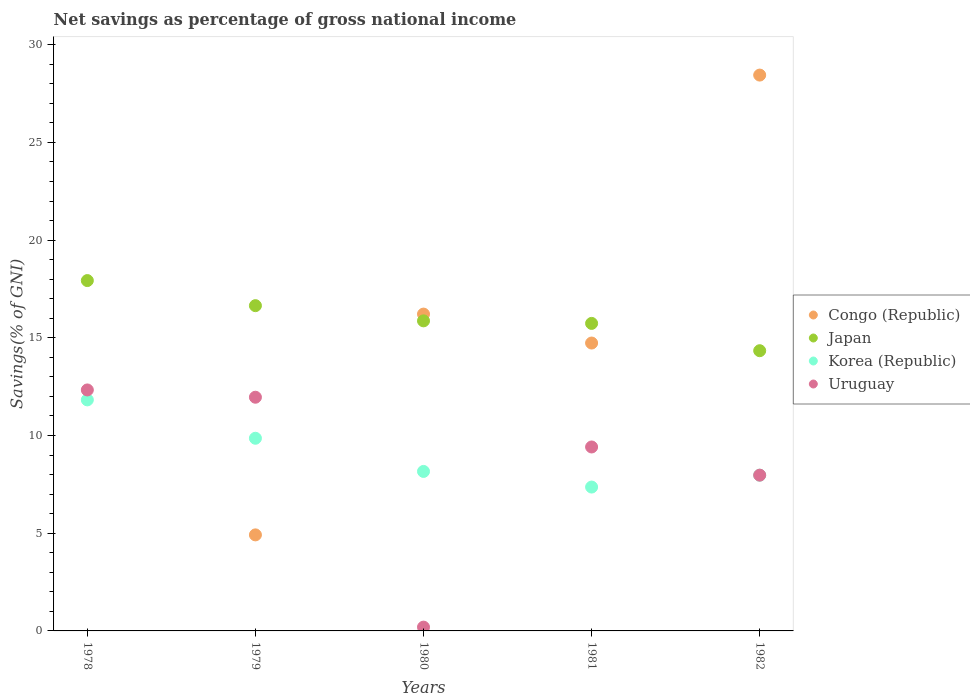What is the total savings in Korea (Republic) in 1979?
Make the answer very short. 9.86. Across all years, what is the maximum total savings in Japan?
Provide a short and direct response. 17.93. Across all years, what is the minimum total savings in Korea (Republic)?
Provide a short and direct response. 7.36. In which year was the total savings in Korea (Republic) maximum?
Give a very brief answer. 1978. What is the total total savings in Congo (Republic) in the graph?
Offer a terse response. 64.31. What is the difference between the total savings in Uruguay in 1979 and that in 1982?
Offer a terse response. 3.99. What is the difference between the total savings in Congo (Republic) in 1978 and the total savings in Uruguay in 1980?
Your answer should be compact. -0.19. What is the average total savings in Japan per year?
Your response must be concise. 16.11. In the year 1980, what is the difference between the total savings in Uruguay and total savings in Congo (Republic)?
Ensure brevity in your answer.  -16.02. What is the ratio of the total savings in Korea (Republic) in 1980 to that in 1982?
Your response must be concise. 1.02. Is the difference between the total savings in Uruguay in 1979 and 1980 greater than the difference between the total savings in Congo (Republic) in 1979 and 1980?
Offer a terse response. Yes. What is the difference between the highest and the second highest total savings in Uruguay?
Keep it short and to the point. 0.37. What is the difference between the highest and the lowest total savings in Uruguay?
Provide a short and direct response. 12.14. In how many years, is the total savings in Uruguay greater than the average total savings in Uruguay taken over all years?
Offer a terse response. 3. Does the total savings in Japan monotonically increase over the years?
Your response must be concise. No. Is the total savings in Japan strictly less than the total savings in Congo (Republic) over the years?
Your answer should be very brief. No. What is the difference between two consecutive major ticks on the Y-axis?
Your answer should be very brief. 5. Does the graph contain any zero values?
Keep it short and to the point. Yes. Does the graph contain grids?
Give a very brief answer. No. Where does the legend appear in the graph?
Your answer should be very brief. Center right. What is the title of the graph?
Provide a succinct answer. Net savings as percentage of gross national income. What is the label or title of the Y-axis?
Offer a very short reply. Savings(% of GNI). What is the Savings(% of GNI) of Japan in 1978?
Give a very brief answer. 17.93. What is the Savings(% of GNI) in Korea (Republic) in 1978?
Your response must be concise. 11.82. What is the Savings(% of GNI) in Uruguay in 1978?
Ensure brevity in your answer.  12.33. What is the Savings(% of GNI) in Congo (Republic) in 1979?
Offer a very short reply. 4.92. What is the Savings(% of GNI) in Japan in 1979?
Provide a short and direct response. 16.65. What is the Savings(% of GNI) of Korea (Republic) in 1979?
Provide a succinct answer. 9.86. What is the Savings(% of GNI) of Uruguay in 1979?
Give a very brief answer. 11.96. What is the Savings(% of GNI) of Congo (Republic) in 1980?
Your answer should be very brief. 16.22. What is the Savings(% of GNI) in Japan in 1980?
Keep it short and to the point. 15.87. What is the Savings(% of GNI) in Korea (Republic) in 1980?
Your answer should be very brief. 8.16. What is the Savings(% of GNI) in Uruguay in 1980?
Provide a succinct answer. 0.19. What is the Savings(% of GNI) in Congo (Republic) in 1981?
Provide a short and direct response. 14.73. What is the Savings(% of GNI) in Japan in 1981?
Make the answer very short. 15.74. What is the Savings(% of GNI) of Korea (Republic) in 1981?
Your response must be concise. 7.36. What is the Savings(% of GNI) in Uruguay in 1981?
Offer a very short reply. 9.41. What is the Savings(% of GNI) of Congo (Republic) in 1982?
Offer a very short reply. 28.45. What is the Savings(% of GNI) in Japan in 1982?
Provide a short and direct response. 14.34. What is the Savings(% of GNI) in Korea (Republic) in 1982?
Your answer should be compact. 7.97. What is the Savings(% of GNI) in Uruguay in 1982?
Offer a very short reply. 7.97. Across all years, what is the maximum Savings(% of GNI) of Congo (Republic)?
Your answer should be very brief. 28.45. Across all years, what is the maximum Savings(% of GNI) in Japan?
Make the answer very short. 17.93. Across all years, what is the maximum Savings(% of GNI) in Korea (Republic)?
Your answer should be very brief. 11.82. Across all years, what is the maximum Savings(% of GNI) in Uruguay?
Give a very brief answer. 12.33. Across all years, what is the minimum Savings(% of GNI) of Japan?
Provide a succinct answer. 14.34. Across all years, what is the minimum Savings(% of GNI) in Korea (Republic)?
Make the answer very short. 7.36. Across all years, what is the minimum Savings(% of GNI) of Uruguay?
Your answer should be very brief. 0.19. What is the total Savings(% of GNI) of Congo (Republic) in the graph?
Your answer should be very brief. 64.31. What is the total Savings(% of GNI) in Japan in the graph?
Your response must be concise. 80.53. What is the total Savings(% of GNI) of Korea (Republic) in the graph?
Give a very brief answer. 45.18. What is the total Savings(% of GNI) in Uruguay in the graph?
Your answer should be very brief. 41.87. What is the difference between the Savings(% of GNI) in Japan in 1978 and that in 1979?
Offer a terse response. 1.28. What is the difference between the Savings(% of GNI) in Korea (Republic) in 1978 and that in 1979?
Ensure brevity in your answer.  1.96. What is the difference between the Savings(% of GNI) of Uruguay in 1978 and that in 1979?
Provide a succinct answer. 0.37. What is the difference between the Savings(% of GNI) of Japan in 1978 and that in 1980?
Give a very brief answer. 2.06. What is the difference between the Savings(% of GNI) of Korea (Republic) in 1978 and that in 1980?
Your response must be concise. 3.66. What is the difference between the Savings(% of GNI) of Uruguay in 1978 and that in 1980?
Give a very brief answer. 12.14. What is the difference between the Savings(% of GNI) in Japan in 1978 and that in 1981?
Your answer should be very brief. 2.19. What is the difference between the Savings(% of GNI) in Korea (Republic) in 1978 and that in 1981?
Provide a succinct answer. 4.46. What is the difference between the Savings(% of GNI) in Uruguay in 1978 and that in 1981?
Offer a very short reply. 2.92. What is the difference between the Savings(% of GNI) in Japan in 1978 and that in 1982?
Provide a short and direct response. 3.59. What is the difference between the Savings(% of GNI) in Korea (Republic) in 1978 and that in 1982?
Offer a very short reply. 3.85. What is the difference between the Savings(% of GNI) of Uruguay in 1978 and that in 1982?
Provide a succinct answer. 4.36. What is the difference between the Savings(% of GNI) of Congo (Republic) in 1979 and that in 1980?
Offer a terse response. -11.3. What is the difference between the Savings(% of GNI) of Korea (Republic) in 1979 and that in 1980?
Make the answer very short. 1.7. What is the difference between the Savings(% of GNI) in Uruguay in 1979 and that in 1980?
Offer a very short reply. 11.77. What is the difference between the Savings(% of GNI) of Congo (Republic) in 1979 and that in 1981?
Your answer should be compact. -9.82. What is the difference between the Savings(% of GNI) of Japan in 1979 and that in 1981?
Your response must be concise. 0.91. What is the difference between the Savings(% of GNI) of Korea (Republic) in 1979 and that in 1981?
Ensure brevity in your answer.  2.5. What is the difference between the Savings(% of GNI) in Uruguay in 1979 and that in 1981?
Give a very brief answer. 2.55. What is the difference between the Savings(% of GNI) in Congo (Republic) in 1979 and that in 1982?
Your response must be concise. -23.53. What is the difference between the Savings(% of GNI) in Japan in 1979 and that in 1982?
Offer a terse response. 2.31. What is the difference between the Savings(% of GNI) in Korea (Republic) in 1979 and that in 1982?
Your response must be concise. 1.89. What is the difference between the Savings(% of GNI) of Uruguay in 1979 and that in 1982?
Keep it short and to the point. 3.99. What is the difference between the Savings(% of GNI) in Congo (Republic) in 1980 and that in 1981?
Provide a short and direct response. 1.48. What is the difference between the Savings(% of GNI) in Japan in 1980 and that in 1981?
Offer a terse response. 0.13. What is the difference between the Savings(% of GNI) of Korea (Republic) in 1980 and that in 1981?
Keep it short and to the point. 0.8. What is the difference between the Savings(% of GNI) of Uruguay in 1980 and that in 1981?
Keep it short and to the point. -9.22. What is the difference between the Savings(% of GNI) of Congo (Republic) in 1980 and that in 1982?
Make the answer very short. -12.23. What is the difference between the Savings(% of GNI) in Japan in 1980 and that in 1982?
Your response must be concise. 1.53. What is the difference between the Savings(% of GNI) in Korea (Republic) in 1980 and that in 1982?
Ensure brevity in your answer.  0.19. What is the difference between the Savings(% of GNI) of Uruguay in 1980 and that in 1982?
Provide a short and direct response. -7.78. What is the difference between the Savings(% of GNI) of Congo (Republic) in 1981 and that in 1982?
Your response must be concise. -13.71. What is the difference between the Savings(% of GNI) of Japan in 1981 and that in 1982?
Your response must be concise. 1.4. What is the difference between the Savings(% of GNI) of Korea (Republic) in 1981 and that in 1982?
Offer a very short reply. -0.61. What is the difference between the Savings(% of GNI) in Uruguay in 1981 and that in 1982?
Give a very brief answer. 1.44. What is the difference between the Savings(% of GNI) in Japan in 1978 and the Savings(% of GNI) in Korea (Republic) in 1979?
Ensure brevity in your answer.  8.07. What is the difference between the Savings(% of GNI) in Japan in 1978 and the Savings(% of GNI) in Uruguay in 1979?
Your response must be concise. 5.97. What is the difference between the Savings(% of GNI) in Korea (Republic) in 1978 and the Savings(% of GNI) in Uruguay in 1979?
Provide a succinct answer. -0.14. What is the difference between the Savings(% of GNI) in Japan in 1978 and the Savings(% of GNI) in Korea (Republic) in 1980?
Offer a very short reply. 9.77. What is the difference between the Savings(% of GNI) of Japan in 1978 and the Savings(% of GNI) of Uruguay in 1980?
Offer a terse response. 17.74. What is the difference between the Savings(% of GNI) in Korea (Republic) in 1978 and the Savings(% of GNI) in Uruguay in 1980?
Your response must be concise. 11.63. What is the difference between the Savings(% of GNI) of Japan in 1978 and the Savings(% of GNI) of Korea (Republic) in 1981?
Your answer should be very brief. 10.57. What is the difference between the Savings(% of GNI) in Japan in 1978 and the Savings(% of GNI) in Uruguay in 1981?
Offer a very short reply. 8.52. What is the difference between the Savings(% of GNI) in Korea (Republic) in 1978 and the Savings(% of GNI) in Uruguay in 1981?
Offer a terse response. 2.41. What is the difference between the Savings(% of GNI) of Japan in 1978 and the Savings(% of GNI) of Korea (Republic) in 1982?
Offer a very short reply. 9.96. What is the difference between the Savings(% of GNI) in Japan in 1978 and the Savings(% of GNI) in Uruguay in 1982?
Your answer should be compact. 9.96. What is the difference between the Savings(% of GNI) of Korea (Republic) in 1978 and the Savings(% of GNI) of Uruguay in 1982?
Your answer should be compact. 3.85. What is the difference between the Savings(% of GNI) in Congo (Republic) in 1979 and the Savings(% of GNI) in Japan in 1980?
Your response must be concise. -10.95. What is the difference between the Savings(% of GNI) in Congo (Republic) in 1979 and the Savings(% of GNI) in Korea (Republic) in 1980?
Your answer should be very brief. -3.25. What is the difference between the Savings(% of GNI) in Congo (Republic) in 1979 and the Savings(% of GNI) in Uruguay in 1980?
Ensure brevity in your answer.  4.72. What is the difference between the Savings(% of GNI) in Japan in 1979 and the Savings(% of GNI) in Korea (Republic) in 1980?
Keep it short and to the point. 8.48. What is the difference between the Savings(% of GNI) in Japan in 1979 and the Savings(% of GNI) in Uruguay in 1980?
Provide a succinct answer. 16.45. What is the difference between the Savings(% of GNI) in Korea (Republic) in 1979 and the Savings(% of GNI) in Uruguay in 1980?
Give a very brief answer. 9.67. What is the difference between the Savings(% of GNI) in Congo (Republic) in 1979 and the Savings(% of GNI) in Japan in 1981?
Your answer should be compact. -10.82. What is the difference between the Savings(% of GNI) of Congo (Republic) in 1979 and the Savings(% of GNI) of Korea (Republic) in 1981?
Keep it short and to the point. -2.45. What is the difference between the Savings(% of GNI) of Congo (Republic) in 1979 and the Savings(% of GNI) of Uruguay in 1981?
Your response must be concise. -4.5. What is the difference between the Savings(% of GNI) in Japan in 1979 and the Savings(% of GNI) in Korea (Republic) in 1981?
Keep it short and to the point. 9.28. What is the difference between the Savings(% of GNI) in Japan in 1979 and the Savings(% of GNI) in Uruguay in 1981?
Ensure brevity in your answer.  7.23. What is the difference between the Savings(% of GNI) in Korea (Republic) in 1979 and the Savings(% of GNI) in Uruguay in 1981?
Offer a very short reply. 0.45. What is the difference between the Savings(% of GNI) in Congo (Republic) in 1979 and the Savings(% of GNI) in Japan in 1982?
Your answer should be very brief. -9.43. What is the difference between the Savings(% of GNI) in Congo (Republic) in 1979 and the Savings(% of GNI) in Korea (Republic) in 1982?
Your answer should be compact. -3.05. What is the difference between the Savings(% of GNI) in Congo (Republic) in 1979 and the Savings(% of GNI) in Uruguay in 1982?
Provide a short and direct response. -3.06. What is the difference between the Savings(% of GNI) in Japan in 1979 and the Savings(% of GNI) in Korea (Republic) in 1982?
Give a very brief answer. 8.68. What is the difference between the Savings(% of GNI) in Japan in 1979 and the Savings(% of GNI) in Uruguay in 1982?
Ensure brevity in your answer.  8.68. What is the difference between the Savings(% of GNI) of Korea (Republic) in 1979 and the Savings(% of GNI) of Uruguay in 1982?
Keep it short and to the point. 1.89. What is the difference between the Savings(% of GNI) of Congo (Republic) in 1980 and the Savings(% of GNI) of Japan in 1981?
Your response must be concise. 0.48. What is the difference between the Savings(% of GNI) of Congo (Republic) in 1980 and the Savings(% of GNI) of Korea (Republic) in 1981?
Your answer should be compact. 8.85. What is the difference between the Savings(% of GNI) of Congo (Republic) in 1980 and the Savings(% of GNI) of Uruguay in 1981?
Your answer should be very brief. 6.8. What is the difference between the Savings(% of GNI) of Japan in 1980 and the Savings(% of GNI) of Korea (Republic) in 1981?
Your answer should be compact. 8.51. What is the difference between the Savings(% of GNI) of Japan in 1980 and the Savings(% of GNI) of Uruguay in 1981?
Provide a short and direct response. 6.45. What is the difference between the Savings(% of GNI) of Korea (Republic) in 1980 and the Savings(% of GNI) of Uruguay in 1981?
Make the answer very short. -1.25. What is the difference between the Savings(% of GNI) of Congo (Republic) in 1980 and the Savings(% of GNI) of Japan in 1982?
Offer a terse response. 1.87. What is the difference between the Savings(% of GNI) in Congo (Republic) in 1980 and the Savings(% of GNI) in Korea (Republic) in 1982?
Offer a terse response. 8.25. What is the difference between the Savings(% of GNI) of Congo (Republic) in 1980 and the Savings(% of GNI) of Uruguay in 1982?
Offer a terse response. 8.24. What is the difference between the Savings(% of GNI) in Japan in 1980 and the Savings(% of GNI) in Korea (Republic) in 1982?
Make the answer very short. 7.9. What is the difference between the Savings(% of GNI) in Japan in 1980 and the Savings(% of GNI) in Uruguay in 1982?
Provide a succinct answer. 7.9. What is the difference between the Savings(% of GNI) in Korea (Republic) in 1980 and the Savings(% of GNI) in Uruguay in 1982?
Provide a short and direct response. 0.19. What is the difference between the Savings(% of GNI) in Congo (Republic) in 1981 and the Savings(% of GNI) in Japan in 1982?
Provide a short and direct response. 0.39. What is the difference between the Savings(% of GNI) of Congo (Republic) in 1981 and the Savings(% of GNI) of Korea (Republic) in 1982?
Ensure brevity in your answer.  6.76. What is the difference between the Savings(% of GNI) of Congo (Republic) in 1981 and the Savings(% of GNI) of Uruguay in 1982?
Your answer should be very brief. 6.76. What is the difference between the Savings(% of GNI) of Japan in 1981 and the Savings(% of GNI) of Korea (Republic) in 1982?
Your answer should be compact. 7.77. What is the difference between the Savings(% of GNI) in Japan in 1981 and the Savings(% of GNI) in Uruguay in 1982?
Offer a terse response. 7.77. What is the difference between the Savings(% of GNI) of Korea (Republic) in 1981 and the Savings(% of GNI) of Uruguay in 1982?
Give a very brief answer. -0.61. What is the average Savings(% of GNI) of Congo (Republic) per year?
Make the answer very short. 12.86. What is the average Savings(% of GNI) in Japan per year?
Provide a short and direct response. 16.11. What is the average Savings(% of GNI) in Korea (Republic) per year?
Offer a terse response. 9.04. What is the average Savings(% of GNI) of Uruguay per year?
Keep it short and to the point. 8.37. In the year 1978, what is the difference between the Savings(% of GNI) of Japan and Savings(% of GNI) of Korea (Republic)?
Provide a succinct answer. 6.11. In the year 1978, what is the difference between the Savings(% of GNI) in Japan and Savings(% of GNI) in Uruguay?
Your response must be concise. 5.6. In the year 1978, what is the difference between the Savings(% of GNI) in Korea (Republic) and Savings(% of GNI) in Uruguay?
Provide a short and direct response. -0.51. In the year 1979, what is the difference between the Savings(% of GNI) of Congo (Republic) and Savings(% of GNI) of Japan?
Provide a short and direct response. -11.73. In the year 1979, what is the difference between the Savings(% of GNI) in Congo (Republic) and Savings(% of GNI) in Korea (Republic)?
Offer a very short reply. -4.95. In the year 1979, what is the difference between the Savings(% of GNI) of Congo (Republic) and Savings(% of GNI) of Uruguay?
Provide a short and direct response. -7.04. In the year 1979, what is the difference between the Savings(% of GNI) in Japan and Savings(% of GNI) in Korea (Republic)?
Offer a very short reply. 6.79. In the year 1979, what is the difference between the Savings(% of GNI) of Japan and Savings(% of GNI) of Uruguay?
Provide a succinct answer. 4.69. In the year 1979, what is the difference between the Savings(% of GNI) in Korea (Republic) and Savings(% of GNI) in Uruguay?
Ensure brevity in your answer.  -2.1. In the year 1980, what is the difference between the Savings(% of GNI) in Congo (Republic) and Savings(% of GNI) in Japan?
Provide a succinct answer. 0.35. In the year 1980, what is the difference between the Savings(% of GNI) of Congo (Republic) and Savings(% of GNI) of Korea (Republic)?
Your answer should be very brief. 8.05. In the year 1980, what is the difference between the Savings(% of GNI) in Congo (Republic) and Savings(% of GNI) in Uruguay?
Make the answer very short. 16.02. In the year 1980, what is the difference between the Savings(% of GNI) in Japan and Savings(% of GNI) in Korea (Republic)?
Provide a short and direct response. 7.71. In the year 1980, what is the difference between the Savings(% of GNI) in Japan and Savings(% of GNI) in Uruguay?
Your answer should be very brief. 15.68. In the year 1980, what is the difference between the Savings(% of GNI) in Korea (Republic) and Savings(% of GNI) in Uruguay?
Offer a terse response. 7.97. In the year 1981, what is the difference between the Savings(% of GNI) of Congo (Republic) and Savings(% of GNI) of Japan?
Your answer should be very brief. -1. In the year 1981, what is the difference between the Savings(% of GNI) in Congo (Republic) and Savings(% of GNI) in Korea (Republic)?
Provide a succinct answer. 7.37. In the year 1981, what is the difference between the Savings(% of GNI) of Congo (Republic) and Savings(% of GNI) of Uruguay?
Your answer should be compact. 5.32. In the year 1981, what is the difference between the Savings(% of GNI) in Japan and Savings(% of GNI) in Korea (Republic)?
Keep it short and to the point. 8.38. In the year 1981, what is the difference between the Savings(% of GNI) in Japan and Savings(% of GNI) in Uruguay?
Offer a terse response. 6.32. In the year 1981, what is the difference between the Savings(% of GNI) of Korea (Republic) and Savings(% of GNI) of Uruguay?
Your answer should be compact. -2.05. In the year 1982, what is the difference between the Savings(% of GNI) in Congo (Republic) and Savings(% of GNI) in Japan?
Your answer should be compact. 14.11. In the year 1982, what is the difference between the Savings(% of GNI) in Congo (Republic) and Savings(% of GNI) in Korea (Republic)?
Offer a very short reply. 20.48. In the year 1982, what is the difference between the Savings(% of GNI) in Congo (Republic) and Savings(% of GNI) in Uruguay?
Offer a very short reply. 20.48. In the year 1982, what is the difference between the Savings(% of GNI) in Japan and Savings(% of GNI) in Korea (Republic)?
Provide a short and direct response. 6.37. In the year 1982, what is the difference between the Savings(% of GNI) of Japan and Savings(% of GNI) of Uruguay?
Provide a short and direct response. 6.37. In the year 1982, what is the difference between the Savings(% of GNI) of Korea (Republic) and Savings(% of GNI) of Uruguay?
Keep it short and to the point. -0. What is the ratio of the Savings(% of GNI) of Japan in 1978 to that in 1979?
Offer a terse response. 1.08. What is the ratio of the Savings(% of GNI) of Korea (Republic) in 1978 to that in 1979?
Give a very brief answer. 1.2. What is the ratio of the Savings(% of GNI) of Uruguay in 1978 to that in 1979?
Offer a terse response. 1.03. What is the ratio of the Savings(% of GNI) in Japan in 1978 to that in 1980?
Your answer should be compact. 1.13. What is the ratio of the Savings(% of GNI) of Korea (Republic) in 1978 to that in 1980?
Provide a short and direct response. 1.45. What is the ratio of the Savings(% of GNI) of Uruguay in 1978 to that in 1980?
Your response must be concise. 63.66. What is the ratio of the Savings(% of GNI) of Japan in 1978 to that in 1981?
Ensure brevity in your answer.  1.14. What is the ratio of the Savings(% of GNI) of Korea (Republic) in 1978 to that in 1981?
Offer a very short reply. 1.61. What is the ratio of the Savings(% of GNI) in Uruguay in 1978 to that in 1981?
Provide a succinct answer. 1.31. What is the ratio of the Savings(% of GNI) in Japan in 1978 to that in 1982?
Make the answer very short. 1.25. What is the ratio of the Savings(% of GNI) in Korea (Republic) in 1978 to that in 1982?
Ensure brevity in your answer.  1.48. What is the ratio of the Savings(% of GNI) in Uruguay in 1978 to that in 1982?
Ensure brevity in your answer.  1.55. What is the ratio of the Savings(% of GNI) in Congo (Republic) in 1979 to that in 1980?
Keep it short and to the point. 0.3. What is the ratio of the Savings(% of GNI) in Japan in 1979 to that in 1980?
Give a very brief answer. 1.05. What is the ratio of the Savings(% of GNI) of Korea (Republic) in 1979 to that in 1980?
Your answer should be very brief. 1.21. What is the ratio of the Savings(% of GNI) of Uruguay in 1979 to that in 1980?
Provide a short and direct response. 61.74. What is the ratio of the Savings(% of GNI) in Congo (Republic) in 1979 to that in 1981?
Keep it short and to the point. 0.33. What is the ratio of the Savings(% of GNI) of Japan in 1979 to that in 1981?
Give a very brief answer. 1.06. What is the ratio of the Savings(% of GNI) of Korea (Republic) in 1979 to that in 1981?
Provide a short and direct response. 1.34. What is the ratio of the Savings(% of GNI) of Uruguay in 1979 to that in 1981?
Offer a terse response. 1.27. What is the ratio of the Savings(% of GNI) of Congo (Republic) in 1979 to that in 1982?
Provide a succinct answer. 0.17. What is the ratio of the Savings(% of GNI) in Japan in 1979 to that in 1982?
Your response must be concise. 1.16. What is the ratio of the Savings(% of GNI) in Korea (Republic) in 1979 to that in 1982?
Make the answer very short. 1.24. What is the ratio of the Savings(% of GNI) of Uruguay in 1979 to that in 1982?
Your answer should be compact. 1.5. What is the ratio of the Savings(% of GNI) of Congo (Republic) in 1980 to that in 1981?
Offer a terse response. 1.1. What is the ratio of the Savings(% of GNI) of Japan in 1980 to that in 1981?
Make the answer very short. 1.01. What is the ratio of the Savings(% of GNI) of Korea (Republic) in 1980 to that in 1981?
Your answer should be compact. 1.11. What is the ratio of the Savings(% of GNI) in Uruguay in 1980 to that in 1981?
Provide a succinct answer. 0.02. What is the ratio of the Savings(% of GNI) in Congo (Republic) in 1980 to that in 1982?
Ensure brevity in your answer.  0.57. What is the ratio of the Savings(% of GNI) of Japan in 1980 to that in 1982?
Ensure brevity in your answer.  1.11. What is the ratio of the Savings(% of GNI) in Korea (Republic) in 1980 to that in 1982?
Your answer should be very brief. 1.02. What is the ratio of the Savings(% of GNI) of Uruguay in 1980 to that in 1982?
Offer a terse response. 0.02. What is the ratio of the Savings(% of GNI) of Congo (Republic) in 1981 to that in 1982?
Ensure brevity in your answer.  0.52. What is the ratio of the Savings(% of GNI) of Japan in 1981 to that in 1982?
Provide a succinct answer. 1.1. What is the ratio of the Savings(% of GNI) in Korea (Republic) in 1981 to that in 1982?
Offer a terse response. 0.92. What is the ratio of the Savings(% of GNI) in Uruguay in 1981 to that in 1982?
Your answer should be compact. 1.18. What is the difference between the highest and the second highest Savings(% of GNI) in Congo (Republic)?
Keep it short and to the point. 12.23. What is the difference between the highest and the second highest Savings(% of GNI) in Japan?
Give a very brief answer. 1.28. What is the difference between the highest and the second highest Savings(% of GNI) in Korea (Republic)?
Give a very brief answer. 1.96. What is the difference between the highest and the second highest Savings(% of GNI) in Uruguay?
Give a very brief answer. 0.37. What is the difference between the highest and the lowest Savings(% of GNI) in Congo (Republic)?
Ensure brevity in your answer.  28.45. What is the difference between the highest and the lowest Savings(% of GNI) in Japan?
Your answer should be compact. 3.59. What is the difference between the highest and the lowest Savings(% of GNI) in Korea (Republic)?
Provide a succinct answer. 4.46. What is the difference between the highest and the lowest Savings(% of GNI) of Uruguay?
Your answer should be compact. 12.14. 